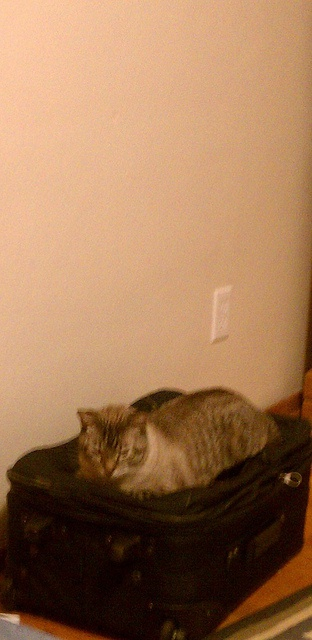Describe the objects in this image and their specific colors. I can see suitcase in tan, black, maroon, and olive tones and cat in tan, maroon, brown, and black tones in this image. 